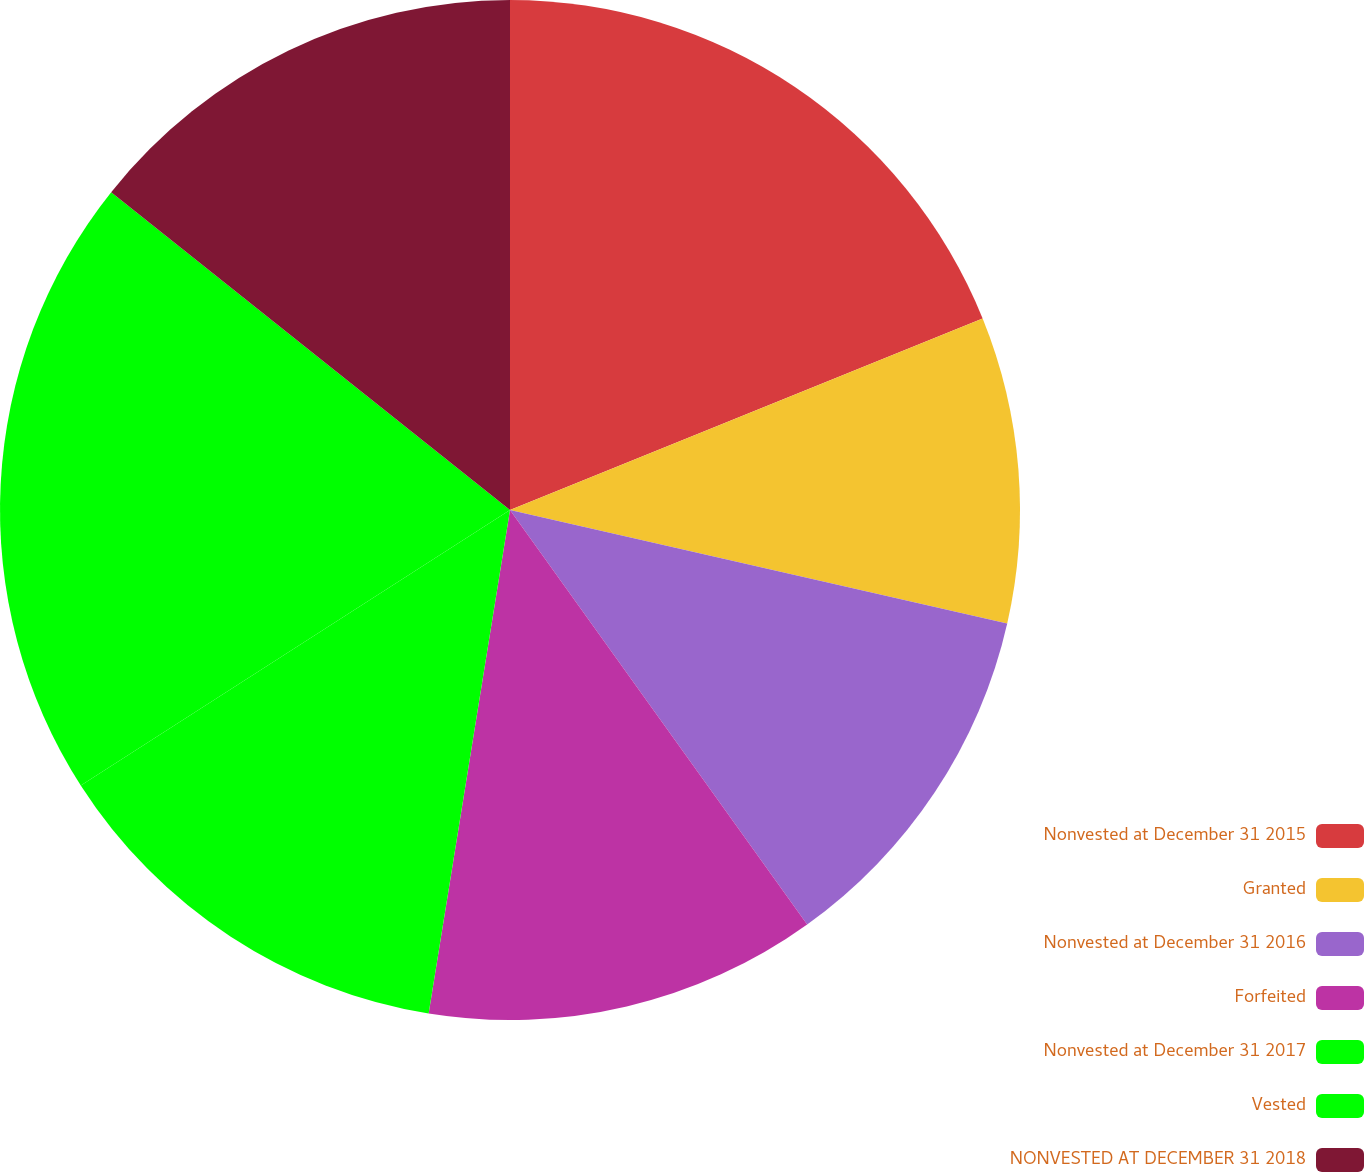Convert chart. <chart><loc_0><loc_0><loc_500><loc_500><pie_chart><fcel>Nonvested at December 31 2015<fcel>Granted<fcel>Nonvested at December 31 2016<fcel>Forfeited<fcel>Nonvested at December 31 2017<fcel>Vested<fcel>NONVESTED AT DECEMBER 31 2018<nl><fcel>18.87%<fcel>9.7%<fcel>11.53%<fcel>12.45%<fcel>13.37%<fcel>19.79%<fcel>14.29%<nl></chart> 